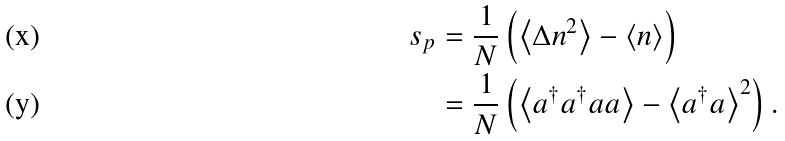Convert formula to latex. <formula><loc_0><loc_0><loc_500><loc_500>s _ { p } & = \frac { 1 } { N } \left ( \left \langle \Delta n ^ { 2 } \right \rangle - \left \langle n \right \rangle \right ) \\ & = \frac { 1 } { N } \left ( \left \langle a ^ { \dagger } a ^ { \dagger } a a \right \rangle - \left \langle a ^ { \dagger } a \right \rangle ^ { 2 } \right ) .</formula> 